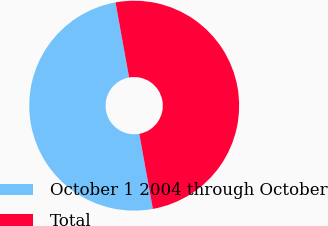Convert chart to OTSL. <chart><loc_0><loc_0><loc_500><loc_500><pie_chart><fcel>October 1 2004 through October<fcel>Total<nl><fcel>50.0%<fcel>50.0%<nl></chart> 